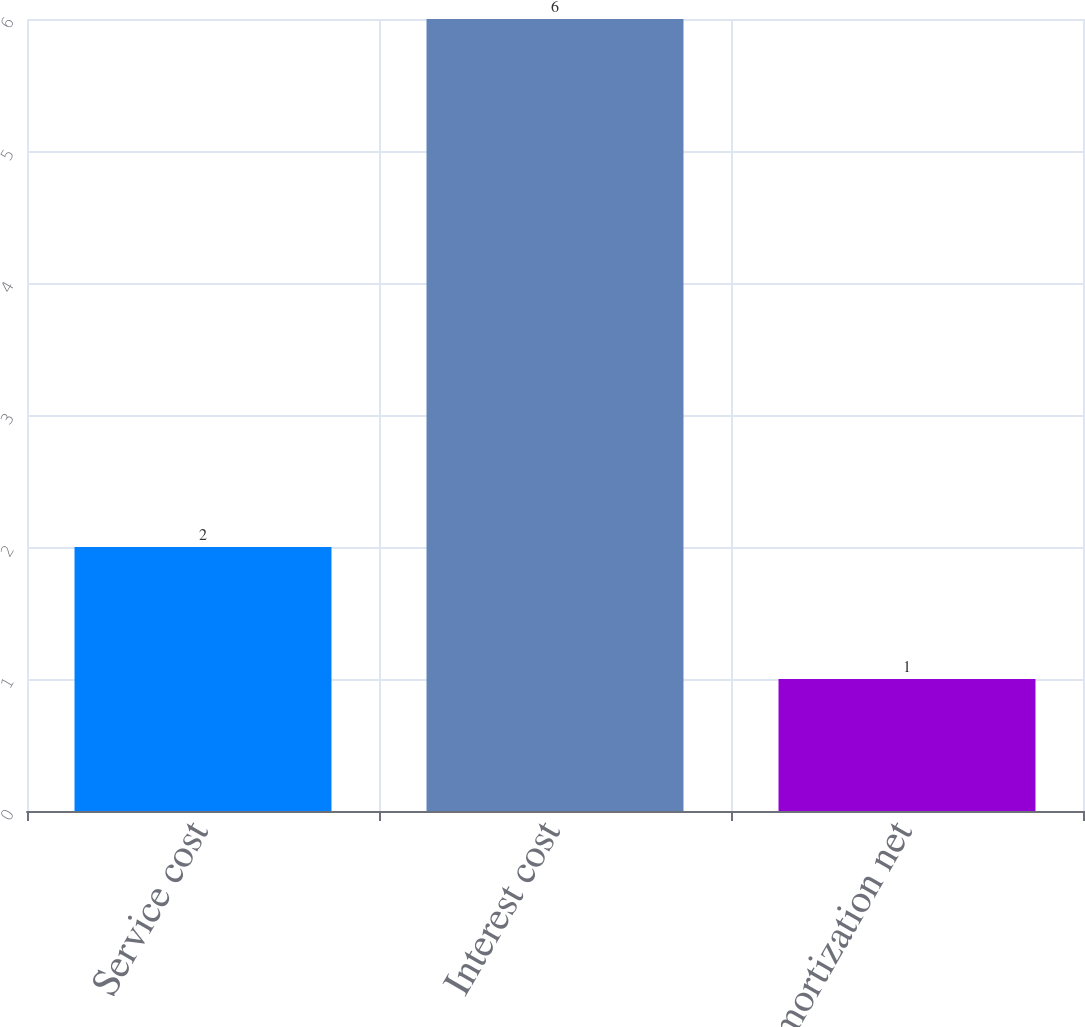Convert chart to OTSL. <chart><loc_0><loc_0><loc_500><loc_500><bar_chart><fcel>Service cost<fcel>Interest cost<fcel>Amortization net<nl><fcel>2<fcel>6<fcel>1<nl></chart> 